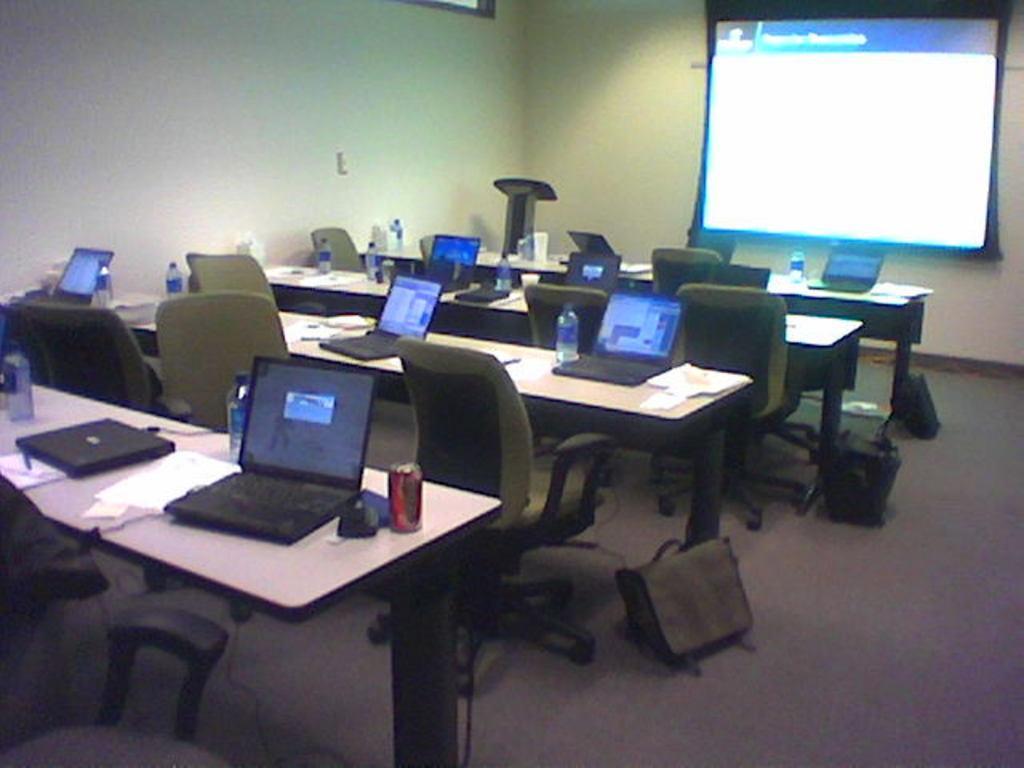Can you describe this image briefly? There are empty chairs in front of a tables which consists of laptops,papers,water bottles on it and there is a projected image in front of it. 